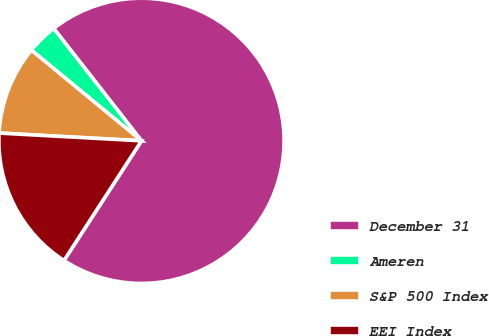<chart> <loc_0><loc_0><loc_500><loc_500><pie_chart><fcel>December 31<fcel>Ameren<fcel>S&P 500 Index<fcel>EEI Index<nl><fcel>69.7%<fcel>3.48%<fcel>10.1%<fcel>16.72%<nl></chart> 